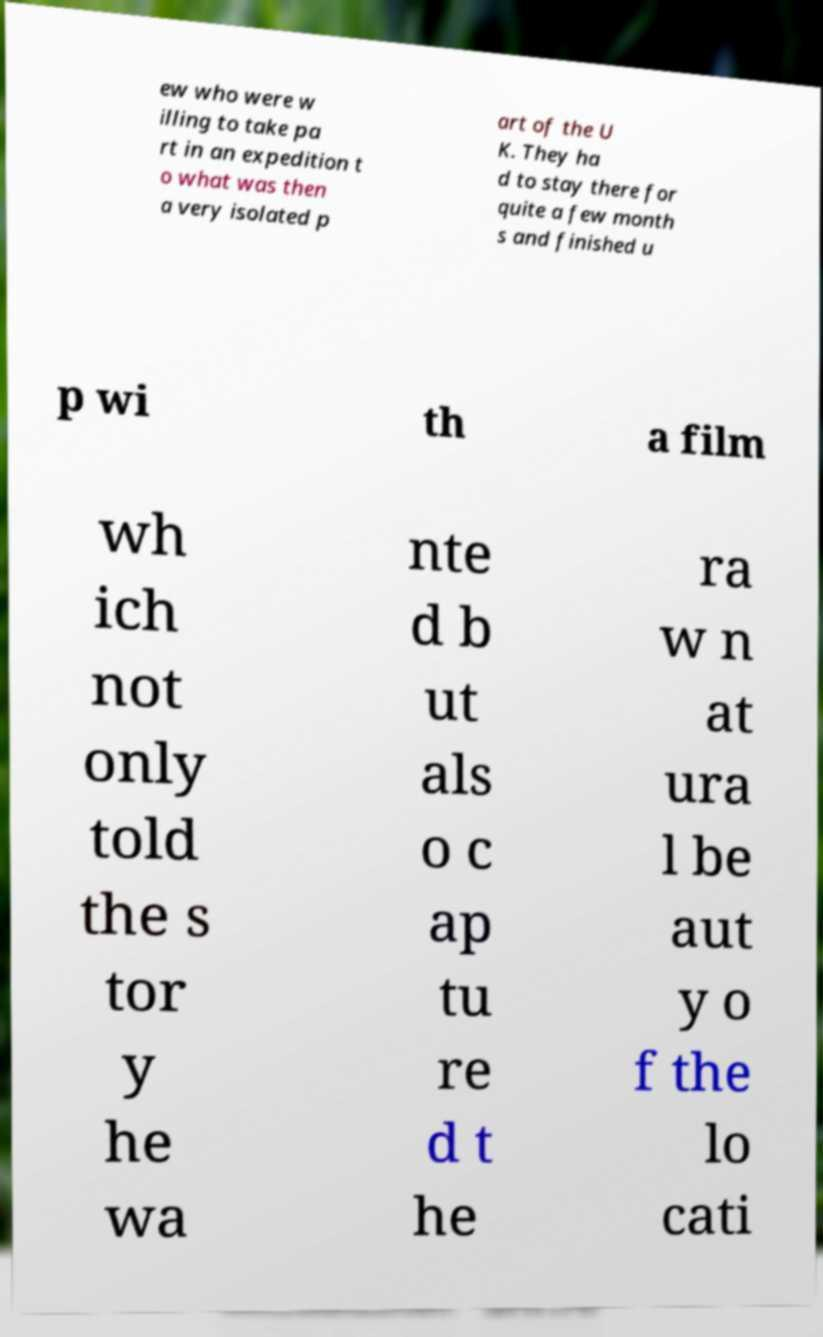There's text embedded in this image that I need extracted. Can you transcribe it verbatim? ew who were w illing to take pa rt in an expedition t o what was then a very isolated p art of the U K. They ha d to stay there for quite a few month s and finished u p wi th a film wh ich not only told the s tor y he wa nte d b ut als o c ap tu re d t he ra w n at ura l be aut y o f the lo cati 